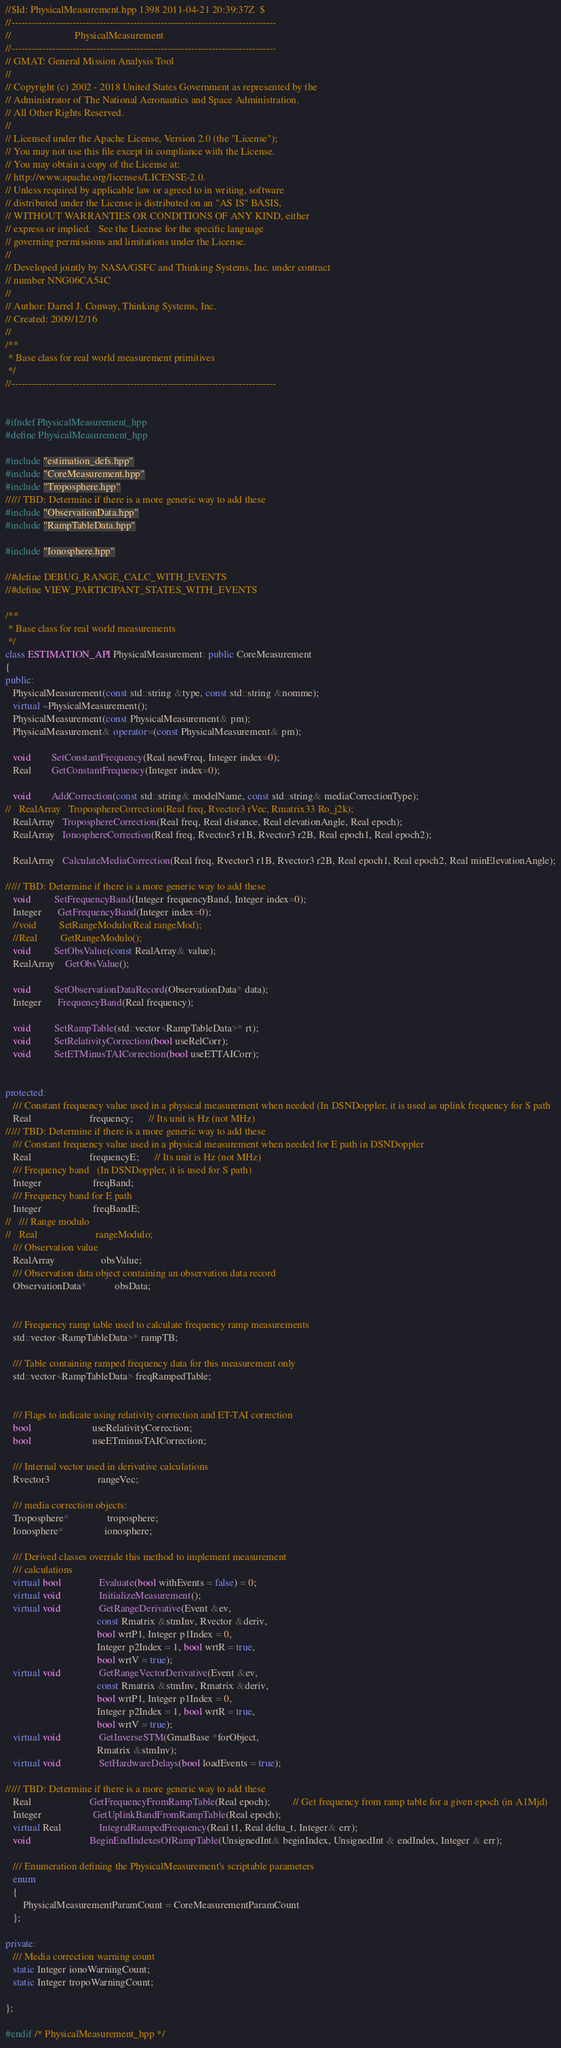<code> <loc_0><loc_0><loc_500><loc_500><_C++_>//$Id: PhysicalMeasurement.hpp 1398 2011-04-21 20:39:37Z  $
//------------------------------------------------------------------------------
//                         PhysicalMeasurement
//------------------------------------------------------------------------------
// GMAT: General Mission Analysis Tool
//
// Copyright (c) 2002 - 2018 United States Government as represented by the
// Administrator of The National Aeronautics and Space Administration.
// All Other Rights Reserved.
//
// Licensed under the Apache License, Version 2.0 (the "License"); 
// You may not use this file except in compliance with the License. 
// You may obtain a copy of the License at:
// http://www.apache.org/licenses/LICENSE-2.0. 
// Unless required by applicable law or agreed to in writing, software
// distributed under the License is distributed on an "AS IS" BASIS,
// WITHOUT WARRANTIES OR CONDITIONS OF ANY KIND, either 
// express or implied.   See the License for the specific language
// governing permissions and limitations under the License.
//
// Developed jointly by NASA/GSFC and Thinking Systems, Inc. under contract
// number NNG06CA54C
//
// Author: Darrel J. Conway, Thinking Systems, Inc.
// Created: 2009/12/16
//
/**
 * Base class for real world measurement primitives
 */
//------------------------------------------------------------------------------


#ifndef PhysicalMeasurement_hpp
#define PhysicalMeasurement_hpp

#include "estimation_defs.hpp"
#include "CoreMeasurement.hpp"
#include "Troposphere.hpp"
///// TBD: Determine if there is a more generic way to add these
#include "ObservationData.hpp"
#include "RampTableData.hpp"

#include "Ionosphere.hpp"

//#define DEBUG_RANGE_CALC_WITH_EVENTS
//#define VIEW_PARTICIPANT_STATES_WITH_EVENTS

/**
 * Base class for real world measurements
 */
class ESTIMATION_API PhysicalMeasurement: public CoreMeasurement
{
public:
   PhysicalMeasurement(const std::string &type, const std::string &nomme);
   virtual ~PhysicalMeasurement();
   PhysicalMeasurement(const PhysicalMeasurement& pm);
   PhysicalMeasurement& operator=(const PhysicalMeasurement& pm);

   void        SetConstantFrequency(Real newFreq, Integer index=0);
   Real        GetConstantFrequency(Integer index=0);

   void        AddCorrection(const std::string& modelName, const std::string& mediaCorrectionType);
//   RealArray   TroposphereCorrection(Real freq, Rvector3 rVec, Rmatrix33 Ro_j2k);
   RealArray   TroposphereCorrection(Real freq, Real distance, Real elevationAngle, Real epoch);
   RealArray   IonosphereCorrection(Real freq, Rvector3 r1B, Rvector3 r2B, Real epoch1, Real epoch2);

   RealArray   CalculateMediaCorrection(Real freq, Rvector3 r1B, Rvector3 r2B, Real epoch1, Real epoch2, Real minElevationAngle);

///// TBD: Determine if there is a more generic way to add these
   void         SetFrequencyBand(Integer frequencyBand, Integer index=0);
   Integer      GetFrequencyBand(Integer index=0);
   //void         SetRangeModulo(Real rangeMod);
   //Real         GetRangeModulo();
   void         SetObsValue(const RealArray& value);
   RealArray    GetObsValue();

   void         SetObservationDataRecord(ObservationData* data);
   Integer      FrequencyBand(Real frequency);

   void         SetRampTable(std::vector<RampTableData>* rt);
   void         SetRelativityCorrection(bool useRelCorr);
   void         SetETMinusTAICorrection(bool useETTAICorr);


protected:
   /// Constant frequency value used in a physical measurement when needed (In DSNDoppler, it is used as uplink frequency for S path
   Real                       frequency;      // Its unit is Hz (not MHz)
///// TBD: Determine if there is a more generic way to add these
   /// Constant frequency value used in a physical measurement when needed for E path in DSNDoppler
   Real                       frequencyE;      // Its unit is Hz (not MHz)
   /// Frequency band   (In DSNDoppler, it is used for S path)
   Integer                    freqBand;
   /// Frequency band for E path
   Integer                    freqBandE;
//   /// Range modulo
//   Real                       rangeModulo;
   /// Observation value
   RealArray                  obsValue;
   /// Observation data object containing an observation data record
   ObservationData*           obsData;


   /// Frequency ramp table used to calculate frequency ramp measurements
   std::vector<RampTableData>* rampTB;

   /// Table containing ramped frequency data for this measurement only
   std::vector<RampTableData> freqRampedTable;


   /// Flags to indicate using relativity correction and ET-TAI correction
   bool                        useRelativityCorrection;
   bool                        useETminusTAICorrection;

   /// Internal vector used in derivative calculations
   Rvector3                   rangeVec;

   /// media correction objects:
   Troposphere*               troposphere;
   Ionosphere*                ionosphere;

   /// Derived classes override this method to implement measurement
   /// calculations
   virtual bool               Evaluate(bool withEvents = false) = 0;
   virtual void               InitializeMeasurement();
   virtual void               GetRangeDerivative(Event &ev,
                                    const Rmatrix &stmInv, Rvector &deriv,
                                    bool wrtP1, Integer p1Index = 0,
                                    Integer p2Index = 1, bool wrtR = true,
                                    bool wrtV = true);
   virtual void               GetRangeVectorDerivative(Event &ev,
                                    const Rmatrix &stmInv, Rmatrix &deriv,
                                    bool wrtP1, Integer p1Index = 0,
                                    Integer p2Index = 1, bool wrtR = true,
                                    bool wrtV = true);
   virtual void               GetInverseSTM(GmatBase *forObject,
                                    Rmatrix &stmInv);
   virtual void               SetHardwareDelays(bool loadEvents = true);

///// TBD: Determine if there is a more generic way to add these
   Real                       GetFrequencyFromRampTable(Real epoch);         // Get frequency from ramp table for a given epoch (in A1Mjd)
   Integer                    GetUplinkBandFromRampTable(Real epoch);
   virtual Real               IntegralRampedFrequency(Real t1, Real delta_t, Integer& err);
   void                       BeginEndIndexesOfRampTable(UnsignedInt& beginIndex, UnsignedInt & endIndex, Integer & err);

   /// Enumeration defining the PhysicalMeasurement's scriptable parameters
   enum
   {
       PhysicalMeasurementParamCount = CoreMeasurementParamCount
   };

private:
   /// Media correction warning count
   static Integer ionoWarningCount;
   static Integer tropoWarningCount;

};

#endif /* PhysicalMeasurement_hpp */
</code> 